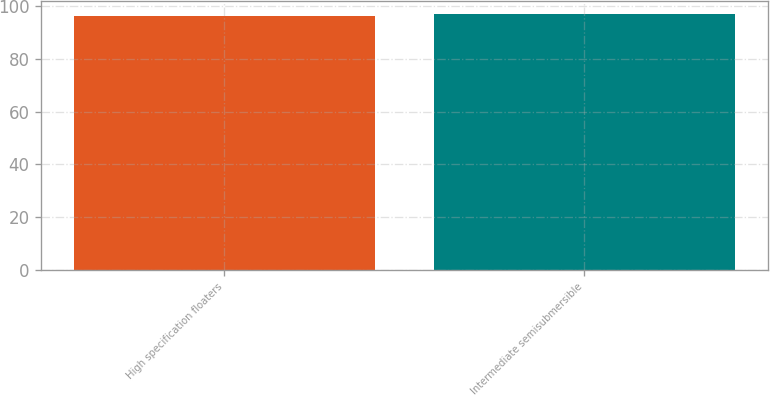Convert chart. <chart><loc_0><loc_0><loc_500><loc_500><bar_chart><fcel>High specification floaters<fcel>Intermediate semisubmersible<nl><fcel>96<fcel>97<nl></chart> 